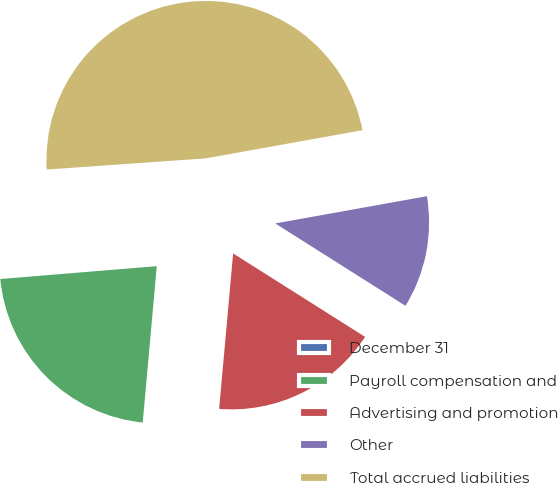Convert chart. <chart><loc_0><loc_0><loc_500><loc_500><pie_chart><fcel>December 31<fcel>Payroll compensation and<fcel>Advertising and promotion<fcel>Other<fcel>Total accrued liabilities<nl><fcel>0.19%<fcel>22.27%<fcel>17.46%<fcel>11.8%<fcel>48.29%<nl></chart> 